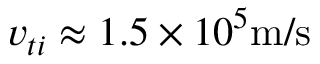<formula> <loc_0><loc_0><loc_500><loc_500>v _ { t i } \approx 1 . 5 \times 1 0 ^ { 5 } m / s</formula> 